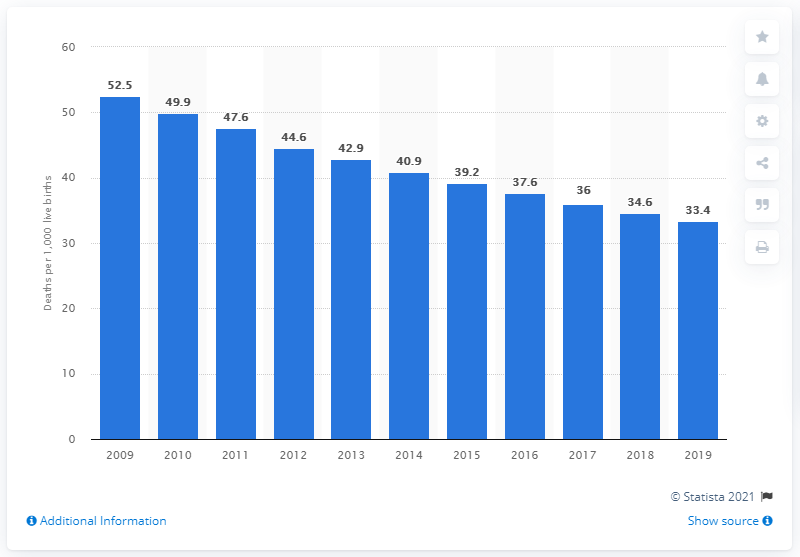Specify some key components in this picture. In 2019, the infant mortality rate in Uganda was 33.4 deaths per 1,000 live births. 